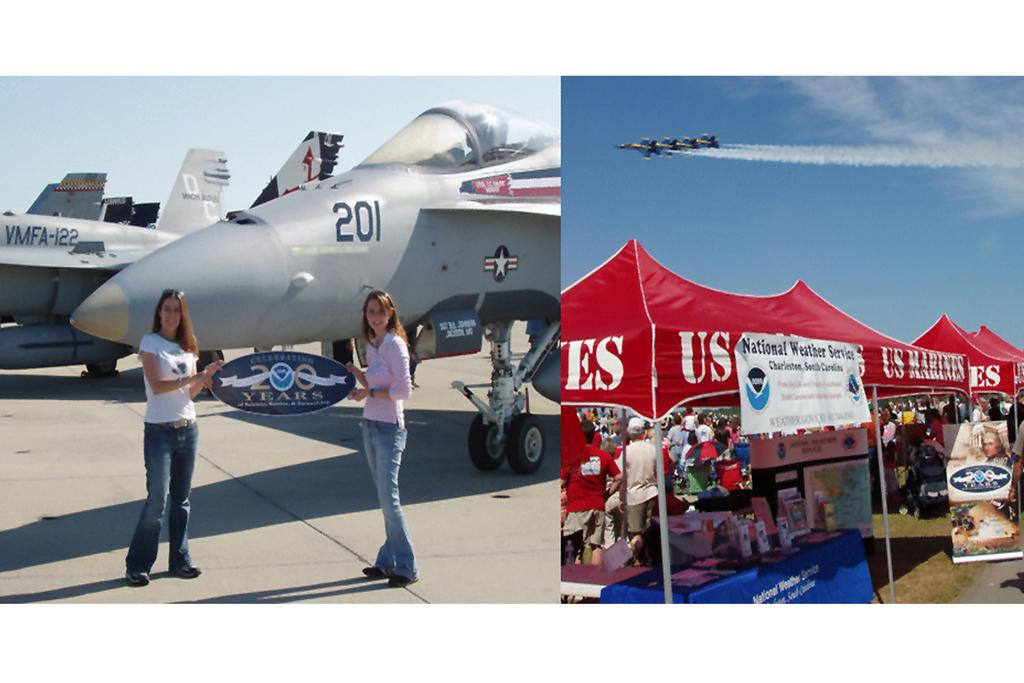Provide a one-sentence caption for the provided image. Two girls hold a sign up in front of an airplane that reads "celebrating 200 years". 